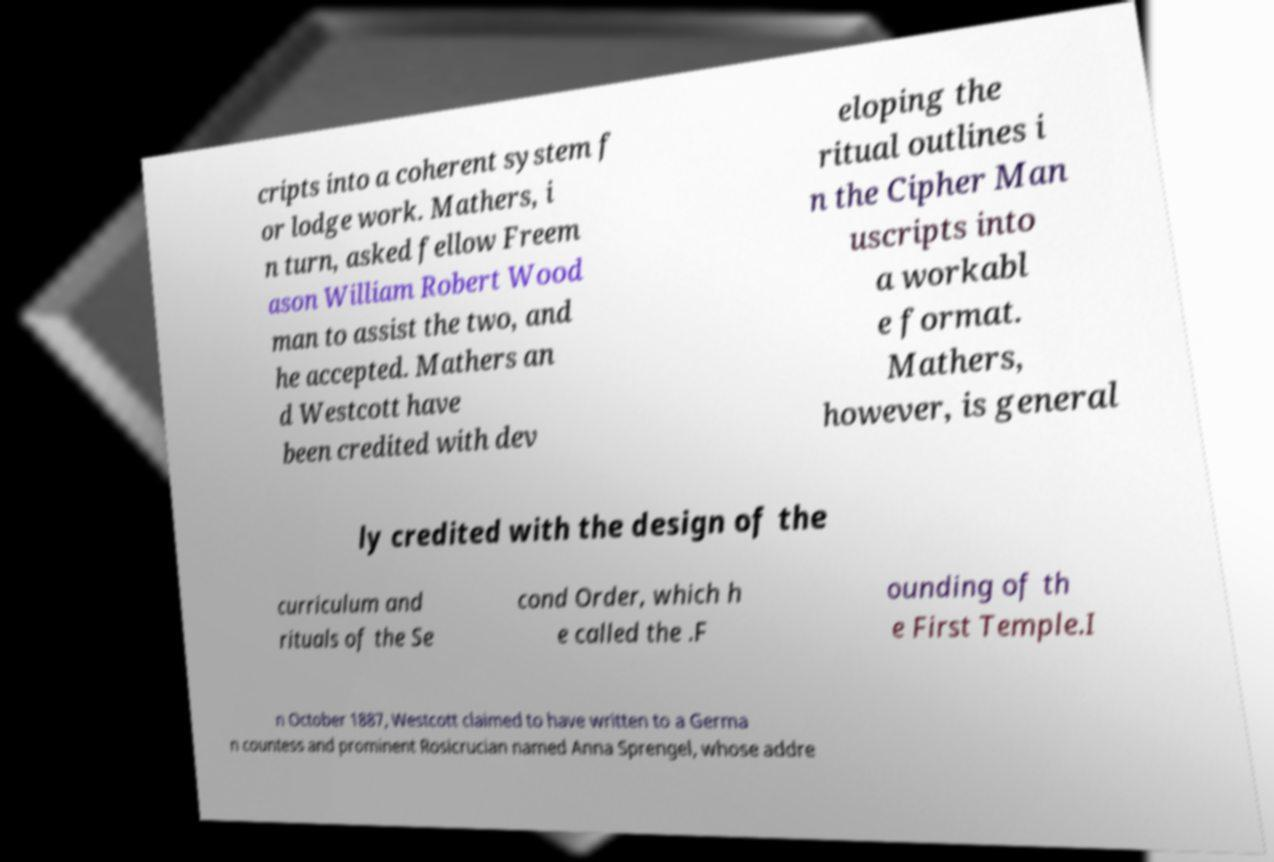Could you assist in decoding the text presented in this image and type it out clearly? cripts into a coherent system f or lodge work. Mathers, i n turn, asked fellow Freem ason William Robert Wood man to assist the two, and he accepted. Mathers an d Westcott have been credited with dev eloping the ritual outlines i n the Cipher Man uscripts into a workabl e format. Mathers, however, is general ly credited with the design of the curriculum and rituals of the Se cond Order, which h e called the .F ounding of th e First Temple.I n October 1887, Westcott claimed to have written to a Germa n countess and prominent Rosicrucian named Anna Sprengel, whose addre 